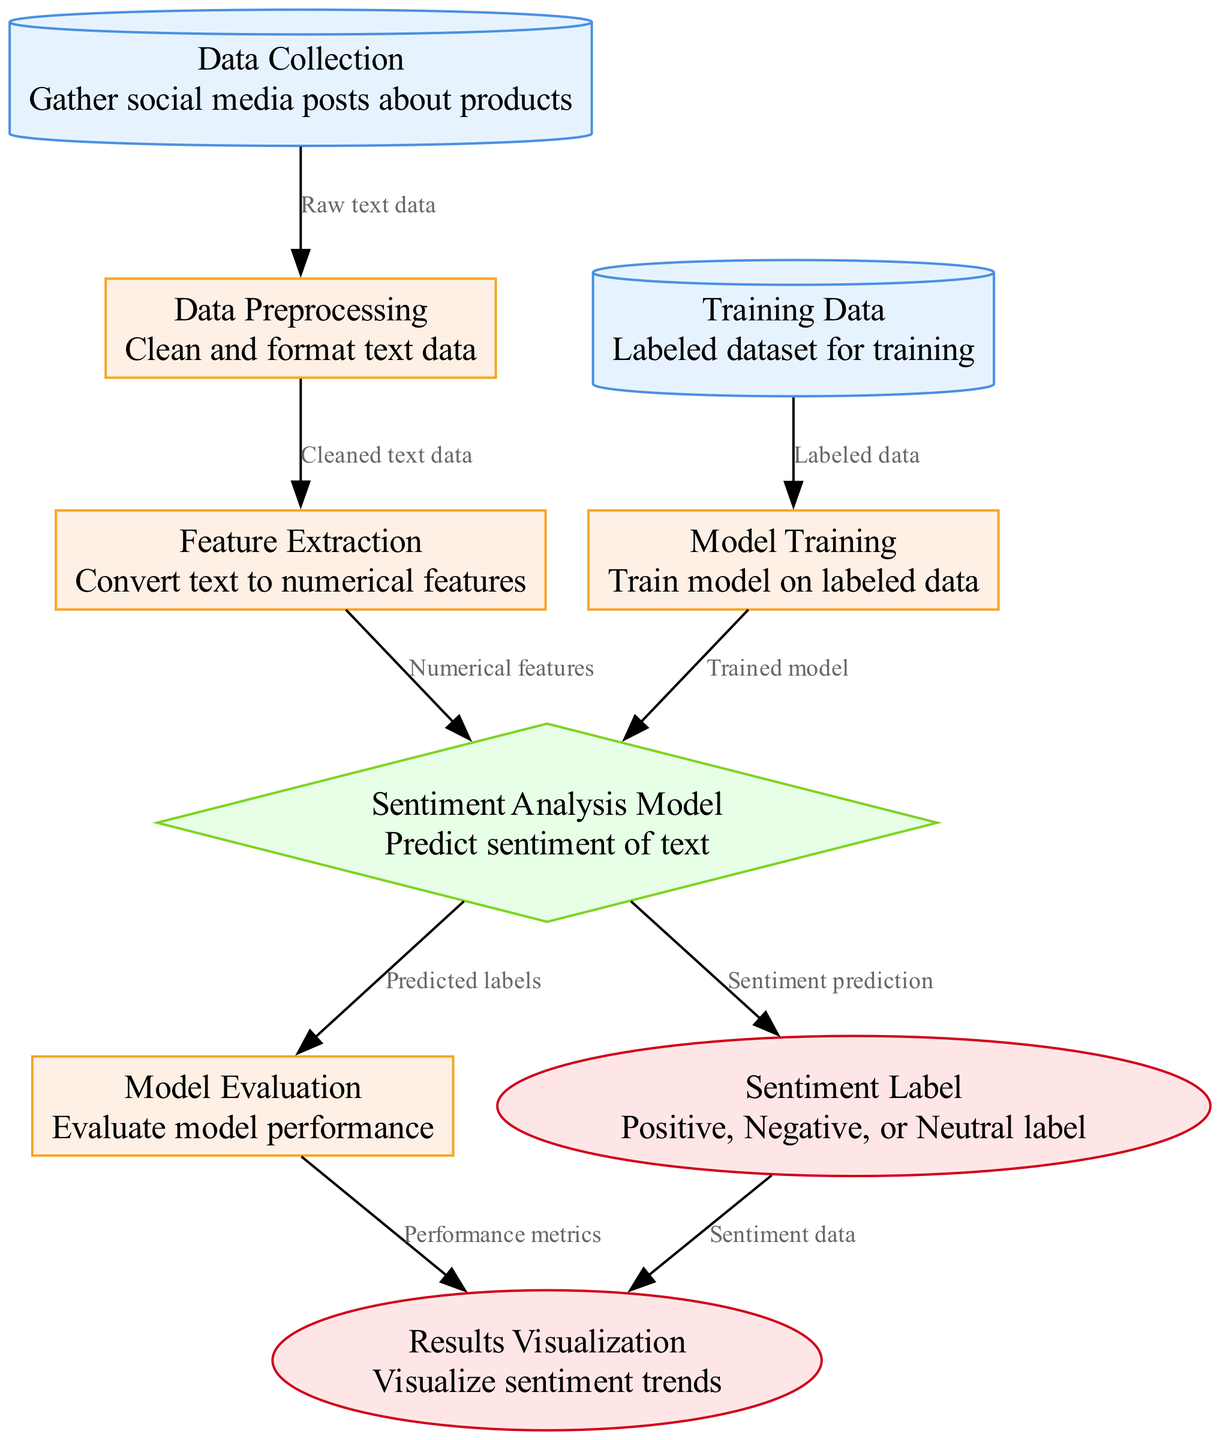What is the first process in the diagram? The diagram starts with the "Data Collection" node that represents the initial step of gathering social media posts about products.
Answer: Data Collection How many nodes are there in the diagram? By counting the nodes listed in the data section, we find there are a total of 9 nodes.
Answer: 9 What type of node is "Sentiment Analysis Model"? Referring to the node types defined in the diagram, "Sentiment Analysis Model" is classified as a model node.
Answer: model Which node receives input directly from "Data Preprocessing"? The node that directly follows "Data Preprocessing" is "Feature Extraction," which receives the cleaned text data as input.
Answer: Feature Extraction What is the output of the "Sentiment Analysis Model"? The output from the "Sentiment Analysis Model" is the "Sentiment Label," which represents the predicted sentiment of the text, categorized into Positive, Negative, or Neutral.
Answer: Sentiment Label What is the purpose of the "Model Evaluation" process? "Model Evaluation" assesses the model's performance based on the predicted labels generated by the "Sentiment Analysis Model," which is crucial for understanding the accuracy and effectiveness of the model.
Answer: Evaluate model performance What are the features converted into during "Feature Extraction"? During "Feature Extraction," text data is converted into numerical features that can be processed by the model for analysis.
Answer: Numerical features Which two nodes are connected by the edge labeled “Trained model”? The edge labeled "Trained model" connects "Model Training" to "Sentiment Analysis Model," indicating that the model is trained using the labeled data.
Answer: Model Training and Sentiment Analysis Model What is visualized at the end of the diagram? At the end of the process, the "Results Visualization" node displays sentiment trends, derived from both sentiment data and performance metrics accumulated throughout the diagram.
Answer: Results Visualization 